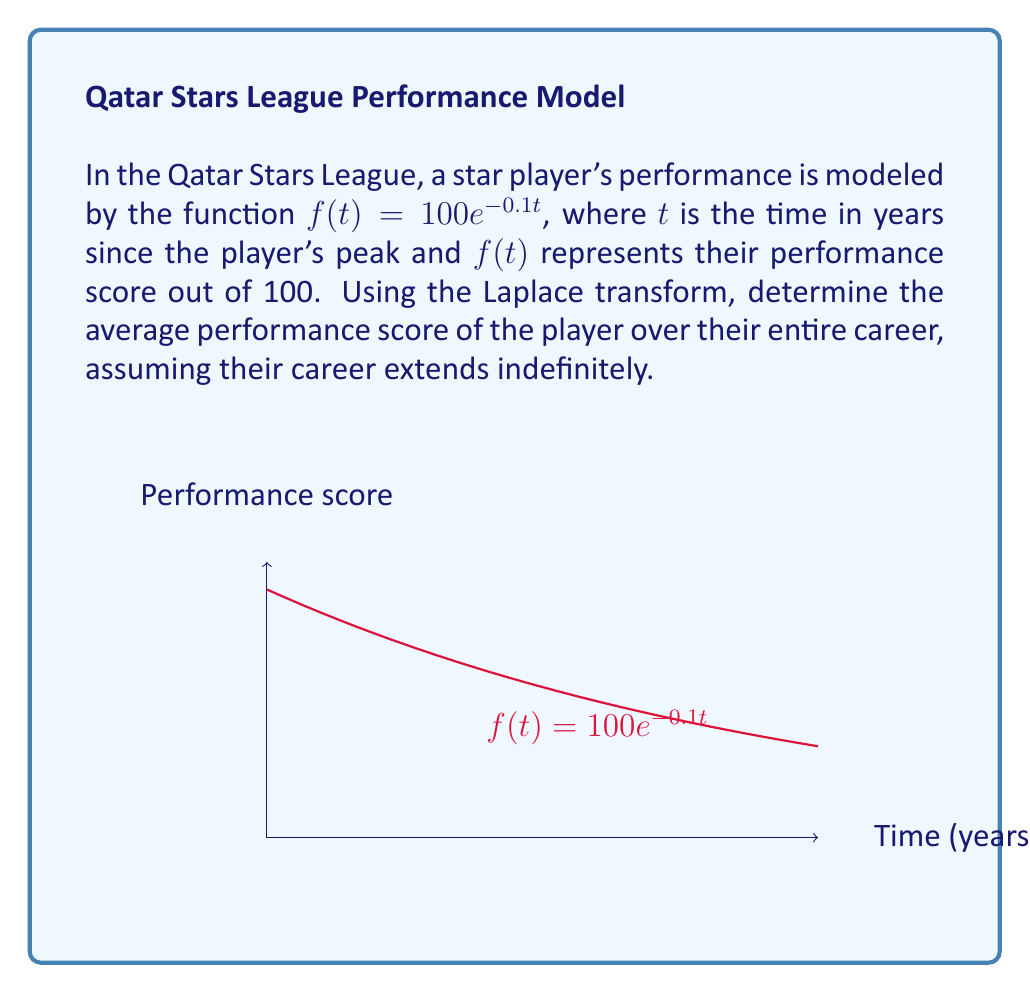What is the answer to this math problem? Let's approach this step-by-step:

1) The Laplace transform of $f(t)$ is given by:

   $$F(s) = \mathcal{L}\{f(t)\} = \int_0^{\infty} f(t)e^{-st} dt$$

2) Substituting our function:

   $$F(s) = \int_0^{\infty} 100e^{-0.1t}e^{-st} dt = 100\int_0^{\infty} e^{-(s+0.1)t} dt$$

3) Evaluating the integral:

   $$F(s) = 100 \left[-\frac{1}{s+0.1}e^{-(s+0.1)t}\right]_0^{\infty} = \frac{100}{s+0.1}$$

4) The average value of a function over an infinite interval is given by:

   $$\lim_{s \to 0} sF(s)$$

5) Applying this to our Laplace transform:

   $$\lim_{s \to 0} s\frac{100}{s+0.1} = \lim_{s \to 0} \frac{100s}{s+0.1}$$

6) Using L'Hôpital's rule:

   $$\lim_{s \to 0} \frac{100s}{s+0.1} = \lim_{s \to 0} \frac{100}{1} = 100$$

7) Therefore, the average performance score over the player's entire career is 100.
Answer: 100 